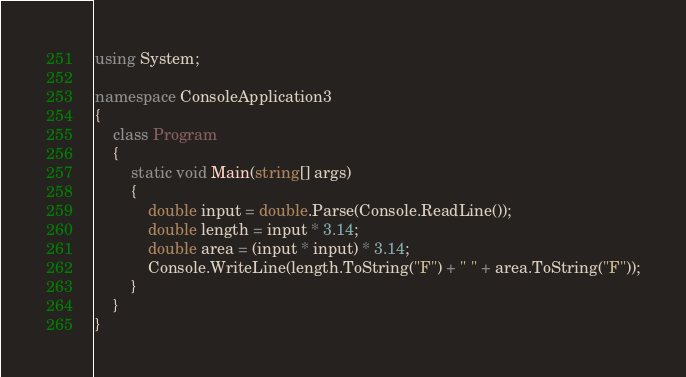Convert code to text. <code><loc_0><loc_0><loc_500><loc_500><_C#_>using System;

namespace ConsoleApplication3
{
    class Program
    {
        static void Main(string[] args)
        {
            double input = double.Parse(Console.ReadLine());
            double length = input * 3.14;
            double area = (input * input) * 3.14;
            Console.WriteLine(length.ToString("F") + " " + area.ToString("F"));
        }
    }
}</code> 